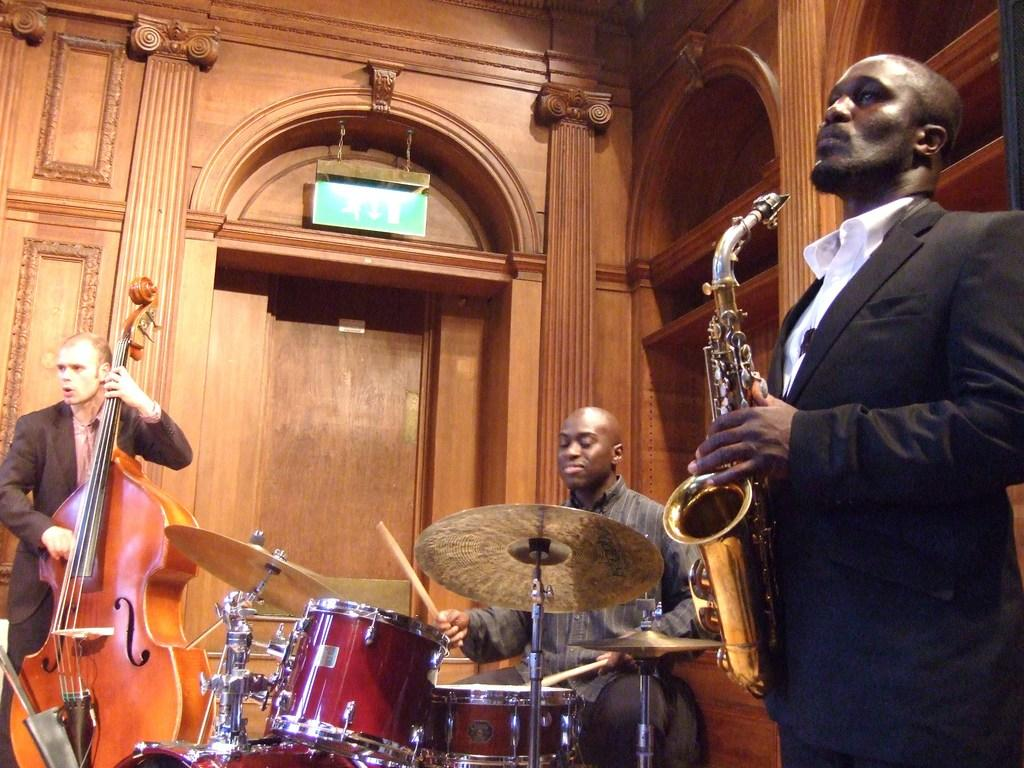What are the men in the image doing? The men in the image are playing musical instruments. Can you identify any specific instruments being played? Yes, there is a drum in the image. How much was the payment for the balloon operation in the image? There is no balloon or payment mentioned in the image; it features a group of men playing musical instruments. 